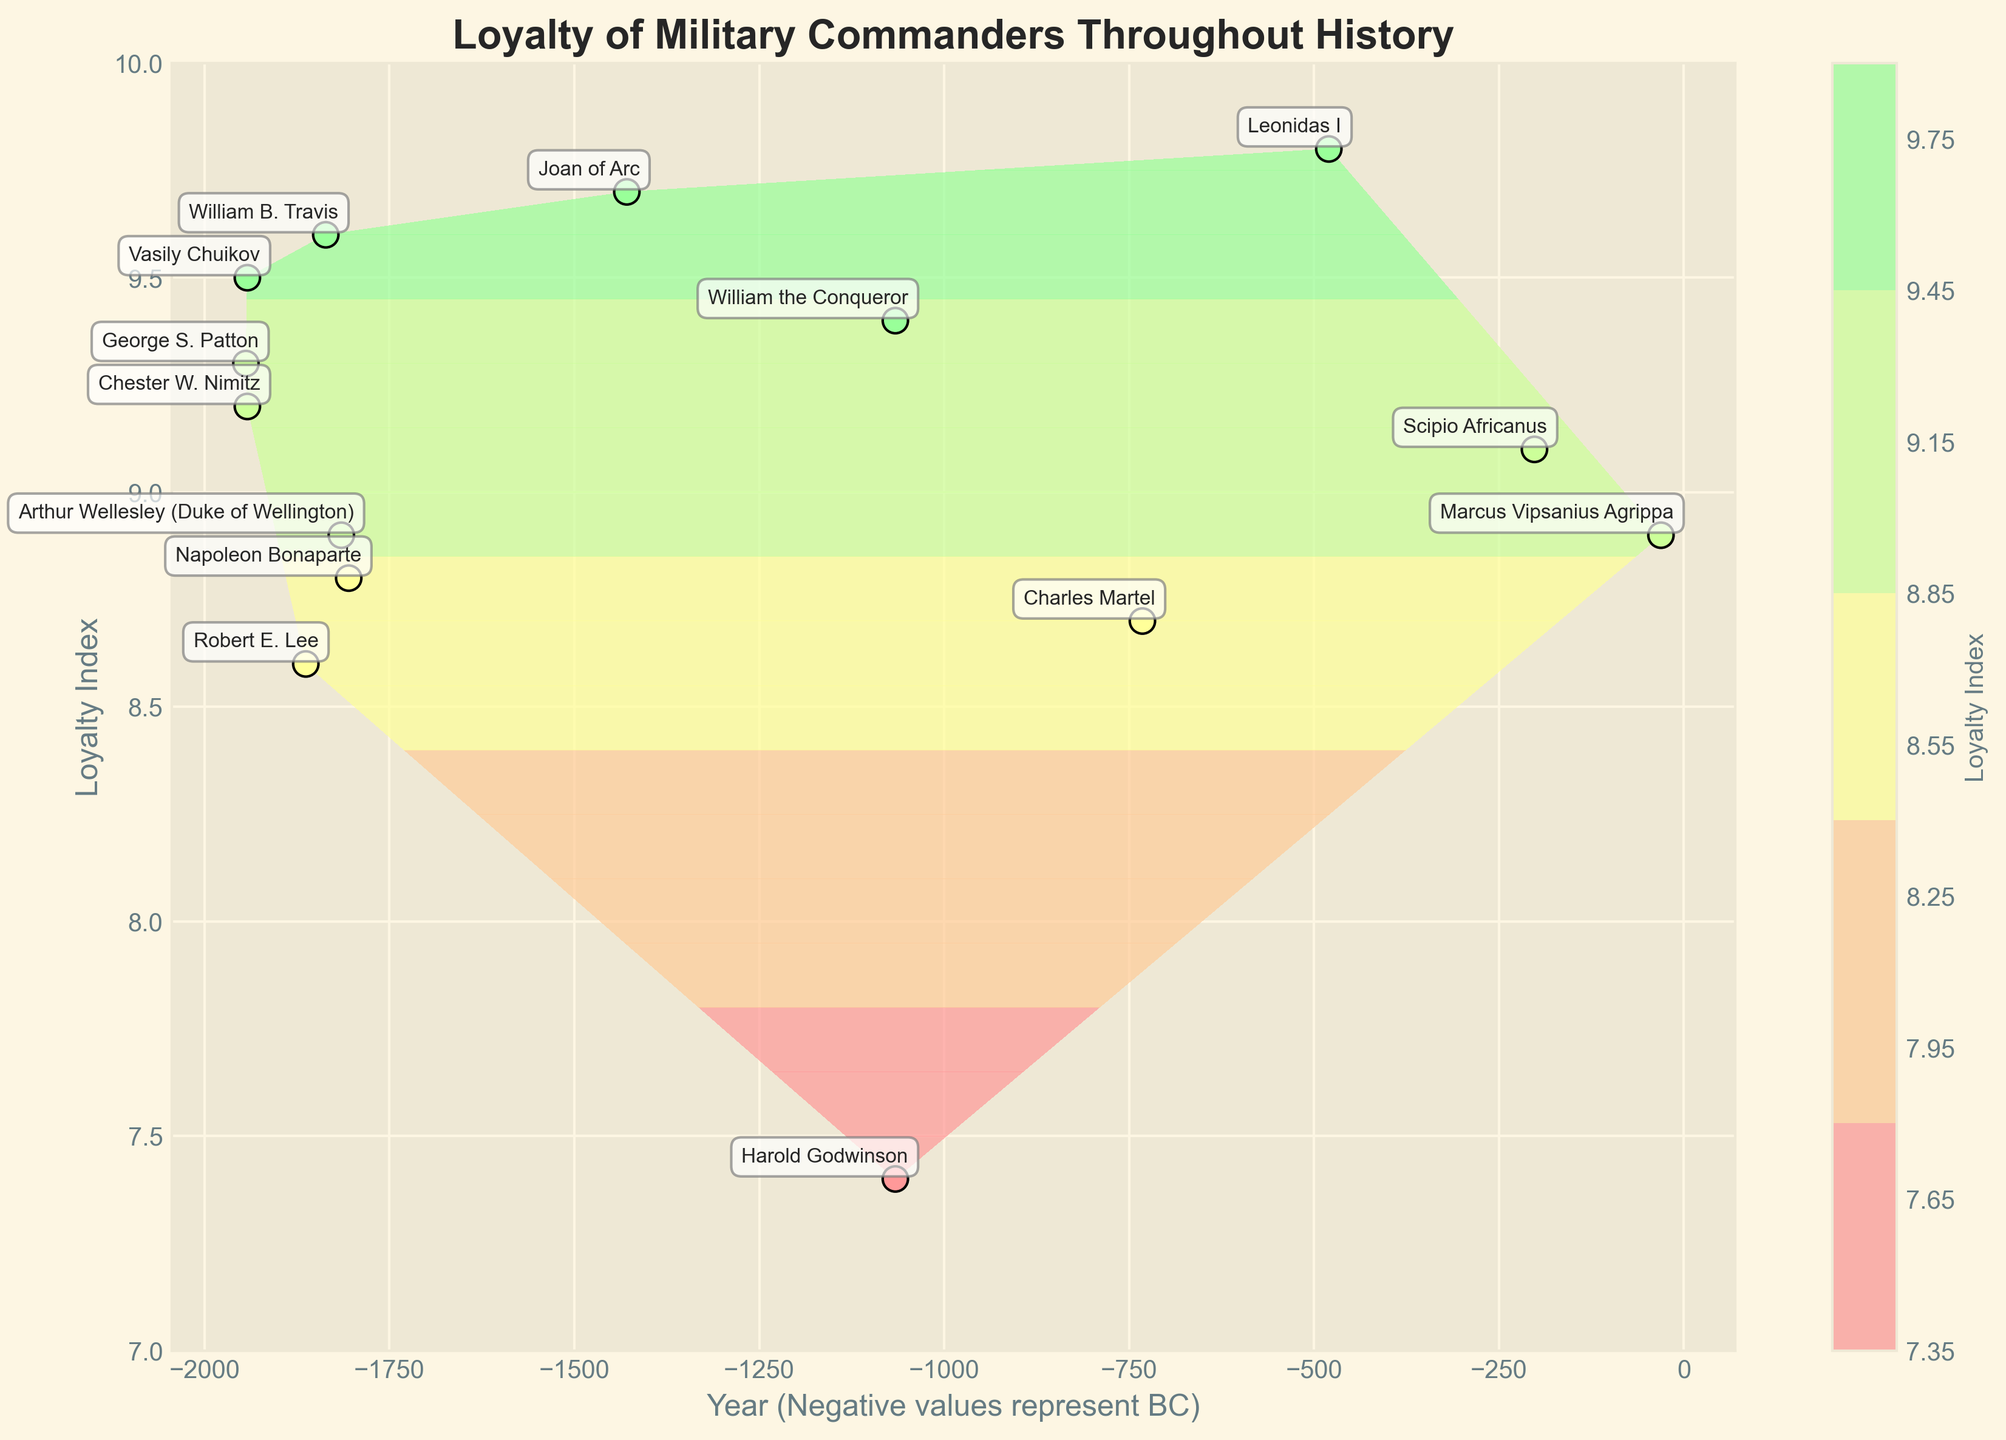What is the title of the plot? The title is prominently displayed at the top of the plot in bold font. It summarizes the main theme of the figure.
Answer: Loyalty of Military Commanders Throughout History How many commanders are represented on the plot? Each point on the plot, along with an annotation, represents a military commander. Counting these points directly gives the number of commanders.
Answer: 14 Which commander has the highest loyalty index? By looking at the loyalty axis and finding the point at the highest position with its annotation, we identify the commander with the highest loyalty index.
Answer: Leonidas I What year represents the oldest battle depicted on the plot? By examining the year axis (negative values for BC) and identifying the point furthest to the left, the oldest battle can be determined.
Answer: 480 BC Which battle occurred in both BC and AD periods? Identifying the repeated data points with close or similar year values across BC and AD periods is the key. The Battle of Hastings, occurring in 1066 AD, can be viewed in context with BC battles but is in AD.
Answer: Battle of Hastings What is the average loyalty index of commanders depicted on the plot? Calculate the average of all the given loyalty indexes by summing them up and dividing by the number of commanders. Sum of all indexes is (9.4 + 9.7 + 8.9 + 8.6 + 9.2 + 8.8 + 9.8 + 7.4 + 9.5 + 9.1 + 8.7 + 9.3 + 8.9 + 9.6) = 126.9. Divide by 14 commanders.
Answer: 9.06 Which commander fought in the Battle of Midway, and what was their loyalty index? Identify the annotation next to the specific battle label and check the corresponding loyalty index displayed on the plot.
Answer: Chester W. Nimitz, 9.2 Compare the loyalty indexes of commanders from the Battle of Hastings. Who was more loyal? Find the points corresponding to the Battle of Hastings and compare their loyalty indexes directly from the plot. William the Conqueror had 9.4 and Harold Godwinson had 7.4.
Answer: William the Conqueror What is the loyalty difference between Vasily Chuikov and Chester W. Nimitz? Subtract Chester W. Nimitz’s loyalty index from Vasily Chuikov’s loyalty index directly from the plot’s loyalty values. Vasily Chuikov has 9.5 and Chester W. Nimitz has 9.2, so the difference is 9.5 - 9.2.
Answer: 0.3 